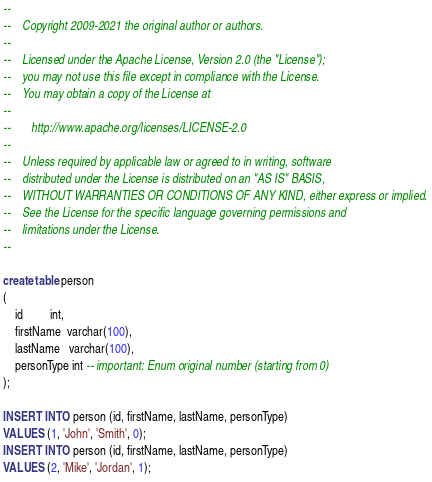<code> <loc_0><loc_0><loc_500><loc_500><_SQL_>--
--    Copyright 2009-2021 the original author or authors.
--
--    Licensed under the Apache License, Version 2.0 (the "License");
--    you may not use this file except in compliance with the License.
--    You may obtain a copy of the License at
--
--       http://www.apache.org/licenses/LICENSE-2.0
--
--    Unless required by applicable law or agreed to in writing, software
--    distributed under the License is distributed on an "AS IS" BASIS,
--    WITHOUT WARRANTIES OR CONDITIONS OF ANY KIND, either express or implied.
--    See the License for the specific language governing permissions and
--    limitations under the License.
--

create table person
(
    id         int,
    firstName  varchar(100),
    lastName   varchar(100),
    personType int -- important: Enum original number (starting from 0)
);

INSERT INTO person (id, firstName, lastName, personType)
VALUES (1, 'John', 'Smith', 0);
INSERT INTO person (id, firstName, lastName, personType)
VALUES (2, 'Mike', 'Jordan', 1);
</code> 